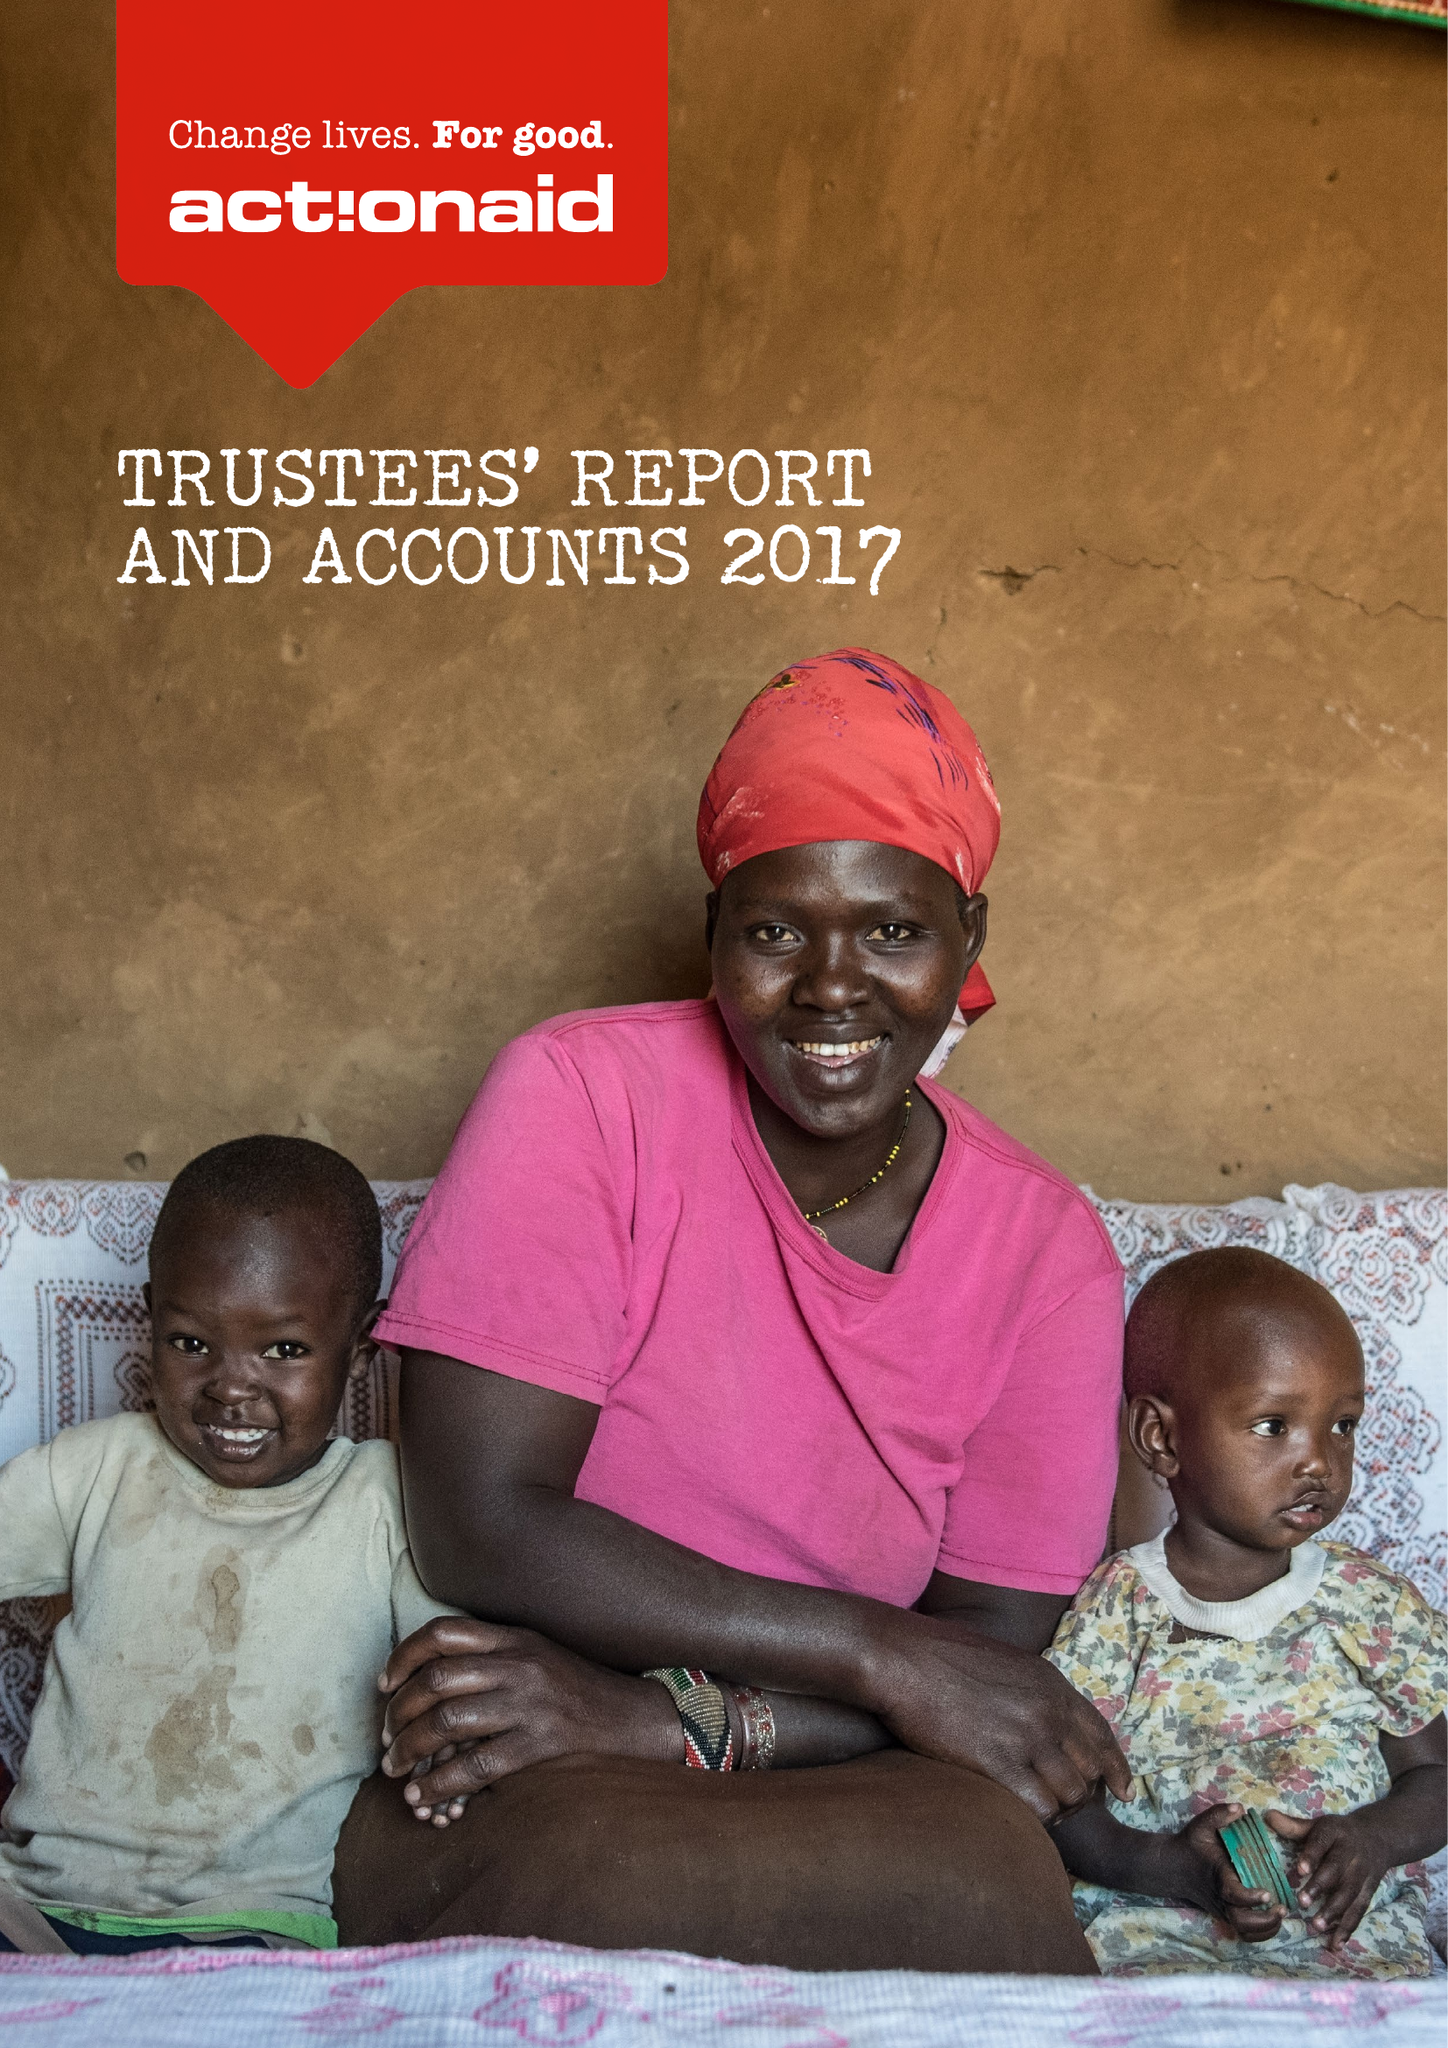What is the value for the charity_name?
Answer the question using a single word or phrase. Actionaid 